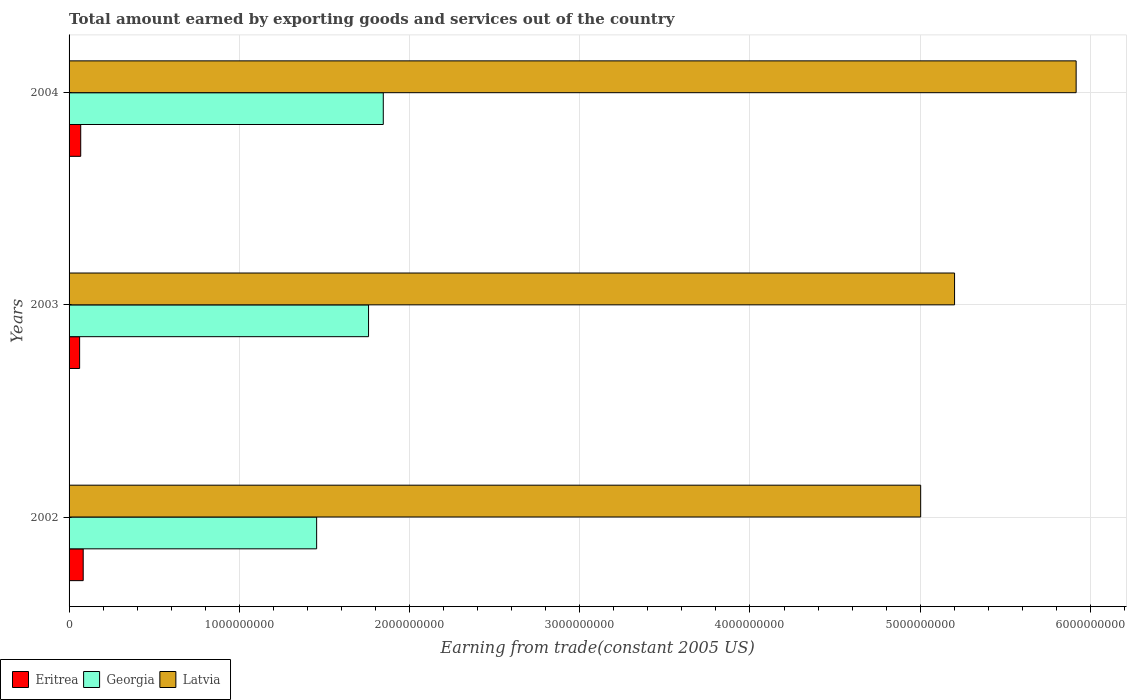How many different coloured bars are there?
Make the answer very short. 3. How many groups of bars are there?
Make the answer very short. 3. How many bars are there on the 1st tick from the bottom?
Make the answer very short. 3. What is the total amount earned by exporting goods and services in Eritrea in 2003?
Ensure brevity in your answer.  6.20e+07. Across all years, what is the maximum total amount earned by exporting goods and services in Eritrea?
Give a very brief answer. 8.30e+07. Across all years, what is the minimum total amount earned by exporting goods and services in Latvia?
Make the answer very short. 5.00e+09. In which year was the total amount earned by exporting goods and services in Eritrea maximum?
Make the answer very short. 2002. What is the total total amount earned by exporting goods and services in Latvia in the graph?
Provide a succinct answer. 1.61e+1. What is the difference between the total amount earned by exporting goods and services in Eritrea in 2003 and that in 2004?
Provide a short and direct response. -6.41e+06. What is the difference between the total amount earned by exporting goods and services in Latvia in 2004 and the total amount earned by exporting goods and services in Georgia in 2003?
Provide a short and direct response. 4.16e+09. What is the average total amount earned by exporting goods and services in Georgia per year?
Your response must be concise. 1.69e+09. In the year 2004, what is the difference between the total amount earned by exporting goods and services in Latvia and total amount earned by exporting goods and services in Eritrea?
Make the answer very short. 5.85e+09. What is the ratio of the total amount earned by exporting goods and services in Latvia in 2002 to that in 2003?
Keep it short and to the point. 0.96. Is the difference between the total amount earned by exporting goods and services in Latvia in 2003 and 2004 greater than the difference between the total amount earned by exporting goods and services in Eritrea in 2003 and 2004?
Your answer should be very brief. No. What is the difference between the highest and the second highest total amount earned by exporting goods and services in Georgia?
Your answer should be very brief. 8.66e+07. What is the difference between the highest and the lowest total amount earned by exporting goods and services in Eritrea?
Make the answer very short. 2.10e+07. In how many years, is the total amount earned by exporting goods and services in Latvia greater than the average total amount earned by exporting goods and services in Latvia taken over all years?
Keep it short and to the point. 1. What does the 3rd bar from the top in 2004 represents?
Keep it short and to the point. Eritrea. What does the 2nd bar from the bottom in 2002 represents?
Your answer should be very brief. Georgia. Is it the case that in every year, the sum of the total amount earned by exporting goods and services in Georgia and total amount earned by exporting goods and services in Latvia is greater than the total amount earned by exporting goods and services in Eritrea?
Give a very brief answer. Yes. How many bars are there?
Your response must be concise. 9. Are all the bars in the graph horizontal?
Keep it short and to the point. Yes. How many years are there in the graph?
Provide a succinct answer. 3. What is the difference between two consecutive major ticks on the X-axis?
Keep it short and to the point. 1.00e+09. Are the values on the major ticks of X-axis written in scientific E-notation?
Your response must be concise. No. Does the graph contain grids?
Give a very brief answer. Yes. Where does the legend appear in the graph?
Your answer should be very brief. Bottom left. What is the title of the graph?
Give a very brief answer. Total amount earned by exporting goods and services out of the country. What is the label or title of the X-axis?
Provide a short and direct response. Earning from trade(constant 2005 US). What is the Earning from trade(constant 2005 US) of Eritrea in 2002?
Offer a very short reply. 8.30e+07. What is the Earning from trade(constant 2005 US) of Georgia in 2002?
Give a very brief answer. 1.45e+09. What is the Earning from trade(constant 2005 US) of Latvia in 2002?
Offer a very short reply. 5.00e+09. What is the Earning from trade(constant 2005 US) in Eritrea in 2003?
Offer a very short reply. 6.20e+07. What is the Earning from trade(constant 2005 US) of Georgia in 2003?
Your answer should be very brief. 1.76e+09. What is the Earning from trade(constant 2005 US) of Latvia in 2003?
Your answer should be compact. 5.20e+09. What is the Earning from trade(constant 2005 US) in Eritrea in 2004?
Ensure brevity in your answer.  6.84e+07. What is the Earning from trade(constant 2005 US) of Georgia in 2004?
Make the answer very short. 1.85e+09. What is the Earning from trade(constant 2005 US) of Latvia in 2004?
Your answer should be compact. 5.92e+09. Across all years, what is the maximum Earning from trade(constant 2005 US) in Eritrea?
Your response must be concise. 8.30e+07. Across all years, what is the maximum Earning from trade(constant 2005 US) in Georgia?
Your answer should be very brief. 1.85e+09. Across all years, what is the maximum Earning from trade(constant 2005 US) in Latvia?
Offer a terse response. 5.92e+09. Across all years, what is the minimum Earning from trade(constant 2005 US) in Eritrea?
Offer a very short reply. 6.20e+07. Across all years, what is the minimum Earning from trade(constant 2005 US) in Georgia?
Keep it short and to the point. 1.45e+09. Across all years, what is the minimum Earning from trade(constant 2005 US) in Latvia?
Ensure brevity in your answer.  5.00e+09. What is the total Earning from trade(constant 2005 US) of Eritrea in the graph?
Provide a succinct answer. 2.13e+08. What is the total Earning from trade(constant 2005 US) of Georgia in the graph?
Offer a terse response. 5.06e+09. What is the total Earning from trade(constant 2005 US) of Latvia in the graph?
Keep it short and to the point. 1.61e+1. What is the difference between the Earning from trade(constant 2005 US) of Eritrea in 2002 and that in 2003?
Your response must be concise. 2.10e+07. What is the difference between the Earning from trade(constant 2005 US) of Georgia in 2002 and that in 2003?
Make the answer very short. -3.05e+08. What is the difference between the Earning from trade(constant 2005 US) in Latvia in 2002 and that in 2003?
Provide a short and direct response. -1.99e+08. What is the difference between the Earning from trade(constant 2005 US) in Eritrea in 2002 and that in 2004?
Your response must be concise. 1.46e+07. What is the difference between the Earning from trade(constant 2005 US) in Georgia in 2002 and that in 2004?
Offer a terse response. -3.92e+08. What is the difference between the Earning from trade(constant 2005 US) in Latvia in 2002 and that in 2004?
Keep it short and to the point. -9.13e+08. What is the difference between the Earning from trade(constant 2005 US) in Eritrea in 2003 and that in 2004?
Your answer should be compact. -6.41e+06. What is the difference between the Earning from trade(constant 2005 US) in Georgia in 2003 and that in 2004?
Offer a very short reply. -8.66e+07. What is the difference between the Earning from trade(constant 2005 US) of Latvia in 2003 and that in 2004?
Provide a short and direct response. -7.14e+08. What is the difference between the Earning from trade(constant 2005 US) of Eritrea in 2002 and the Earning from trade(constant 2005 US) of Georgia in 2003?
Your answer should be compact. -1.68e+09. What is the difference between the Earning from trade(constant 2005 US) of Eritrea in 2002 and the Earning from trade(constant 2005 US) of Latvia in 2003?
Offer a terse response. -5.12e+09. What is the difference between the Earning from trade(constant 2005 US) in Georgia in 2002 and the Earning from trade(constant 2005 US) in Latvia in 2003?
Keep it short and to the point. -3.75e+09. What is the difference between the Earning from trade(constant 2005 US) of Eritrea in 2002 and the Earning from trade(constant 2005 US) of Georgia in 2004?
Your answer should be compact. -1.76e+09. What is the difference between the Earning from trade(constant 2005 US) in Eritrea in 2002 and the Earning from trade(constant 2005 US) in Latvia in 2004?
Your answer should be compact. -5.83e+09. What is the difference between the Earning from trade(constant 2005 US) of Georgia in 2002 and the Earning from trade(constant 2005 US) of Latvia in 2004?
Your answer should be very brief. -4.46e+09. What is the difference between the Earning from trade(constant 2005 US) of Eritrea in 2003 and the Earning from trade(constant 2005 US) of Georgia in 2004?
Offer a terse response. -1.78e+09. What is the difference between the Earning from trade(constant 2005 US) in Eritrea in 2003 and the Earning from trade(constant 2005 US) in Latvia in 2004?
Give a very brief answer. -5.85e+09. What is the difference between the Earning from trade(constant 2005 US) in Georgia in 2003 and the Earning from trade(constant 2005 US) in Latvia in 2004?
Keep it short and to the point. -4.16e+09. What is the average Earning from trade(constant 2005 US) of Eritrea per year?
Offer a very short reply. 7.11e+07. What is the average Earning from trade(constant 2005 US) of Georgia per year?
Ensure brevity in your answer.  1.69e+09. What is the average Earning from trade(constant 2005 US) of Latvia per year?
Your answer should be very brief. 5.37e+09. In the year 2002, what is the difference between the Earning from trade(constant 2005 US) in Eritrea and Earning from trade(constant 2005 US) in Georgia?
Provide a succinct answer. -1.37e+09. In the year 2002, what is the difference between the Earning from trade(constant 2005 US) in Eritrea and Earning from trade(constant 2005 US) in Latvia?
Keep it short and to the point. -4.92e+09. In the year 2002, what is the difference between the Earning from trade(constant 2005 US) in Georgia and Earning from trade(constant 2005 US) in Latvia?
Your response must be concise. -3.55e+09. In the year 2003, what is the difference between the Earning from trade(constant 2005 US) of Eritrea and Earning from trade(constant 2005 US) of Georgia?
Your answer should be compact. -1.70e+09. In the year 2003, what is the difference between the Earning from trade(constant 2005 US) in Eritrea and Earning from trade(constant 2005 US) in Latvia?
Offer a terse response. -5.14e+09. In the year 2003, what is the difference between the Earning from trade(constant 2005 US) of Georgia and Earning from trade(constant 2005 US) of Latvia?
Provide a short and direct response. -3.44e+09. In the year 2004, what is the difference between the Earning from trade(constant 2005 US) in Eritrea and Earning from trade(constant 2005 US) in Georgia?
Offer a terse response. -1.78e+09. In the year 2004, what is the difference between the Earning from trade(constant 2005 US) of Eritrea and Earning from trade(constant 2005 US) of Latvia?
Provide a short and direct response. -5.85e+09. In the year 2004, what is the difference between the Earning from trade(constant 2005 US) of Georgia and Earning from trade(constant 2005 US) of Latvia?
Ensure brevity in your answer.  -4.07e+09. What is the ratio of the Earning from trade(constant 2005 US) in Eritrea in 2002 to that in 2003?
Ensure brevity in your answer.  1.34. What is the ratio of the Earning from trade(constant 2005 US) in Georgia in 2002 to that in 2003?
Keep it short and to the point. 0.83. What is the ratio of the Earning from trade(constant 2005 US) in Latvia in 2002 to that in 2003?
Your answer should be very brief. 0.96. What is the ratio of the Earning from trade(constant 2005 US) in Eritrea in 2002 to that in 2004?
Keep it short and to the point. 1.21. What is the ratio of the Earning from trade(constant 2005 US) in Georgia in 2002 to that in 2004?
Make the answer very short. 0.79. What is the ratio of the Earning from trade(constant 2005 US) of Latvia in 2002 to that in 2004?
Make the answer very short. 0.85. What is the ratio of the Earning from trade(constant 2005 US) of Eritrea in 2003 to that in 2004?
Offer a very short reply. 0.91. What is the ratio of the Earning from trade(constant 2005 US) in Georgia in 2003 to that in 2004?
Make the answer very short. 0.95. What is the ratio of the Earning from trade(constant 2005 US) in Latvia in 2003 to that in 2004?
Offer a terse response. 0.88. What is the difference between the highest and the second highest Earning from trade(constant 2005 US) of Eritrea?
Your answer should be very brief. 1.46e+07. What is the difference between the highest and the second highest Earning from trade(constant 2005 US) in Georgia?
Offer a terse response. 8.66e+07. What is the difference between the highest and the second highest Earning from trade(constant 2005 US) in Latvia?
Offer a terse response. 7.14e+08. What is the difference between the highest and the lowest Earning from trade(constant 2005 US) in Eritrea?
Offer a terse response. 2.10e+07. What is the difference between the highest and the lowest Earning from trade(constant 2005 US) in Georgia?
Ensure brevity in your answer.  3.92e+08. What is the difference between the highest and the lowest Earning from trade(constant 2005 US) in Latvia?
Your response must be concise. 9.13e+08. 